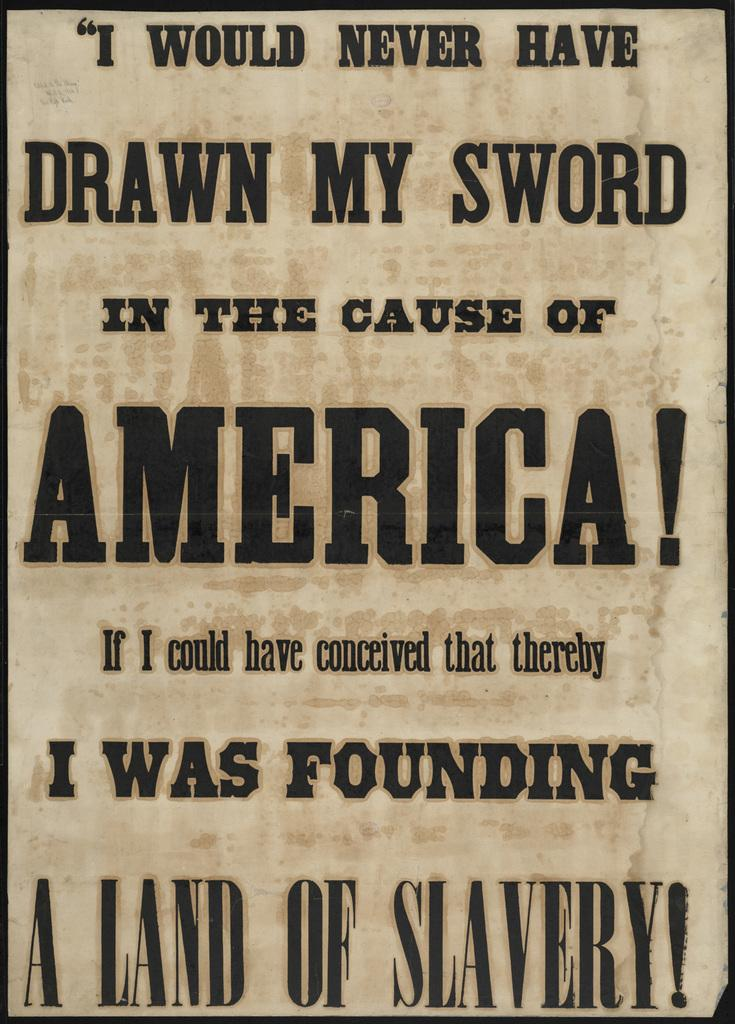<image>
Render a clear and concise summary of the photo. a poster that says 'a land of slavery!' at the bottom 